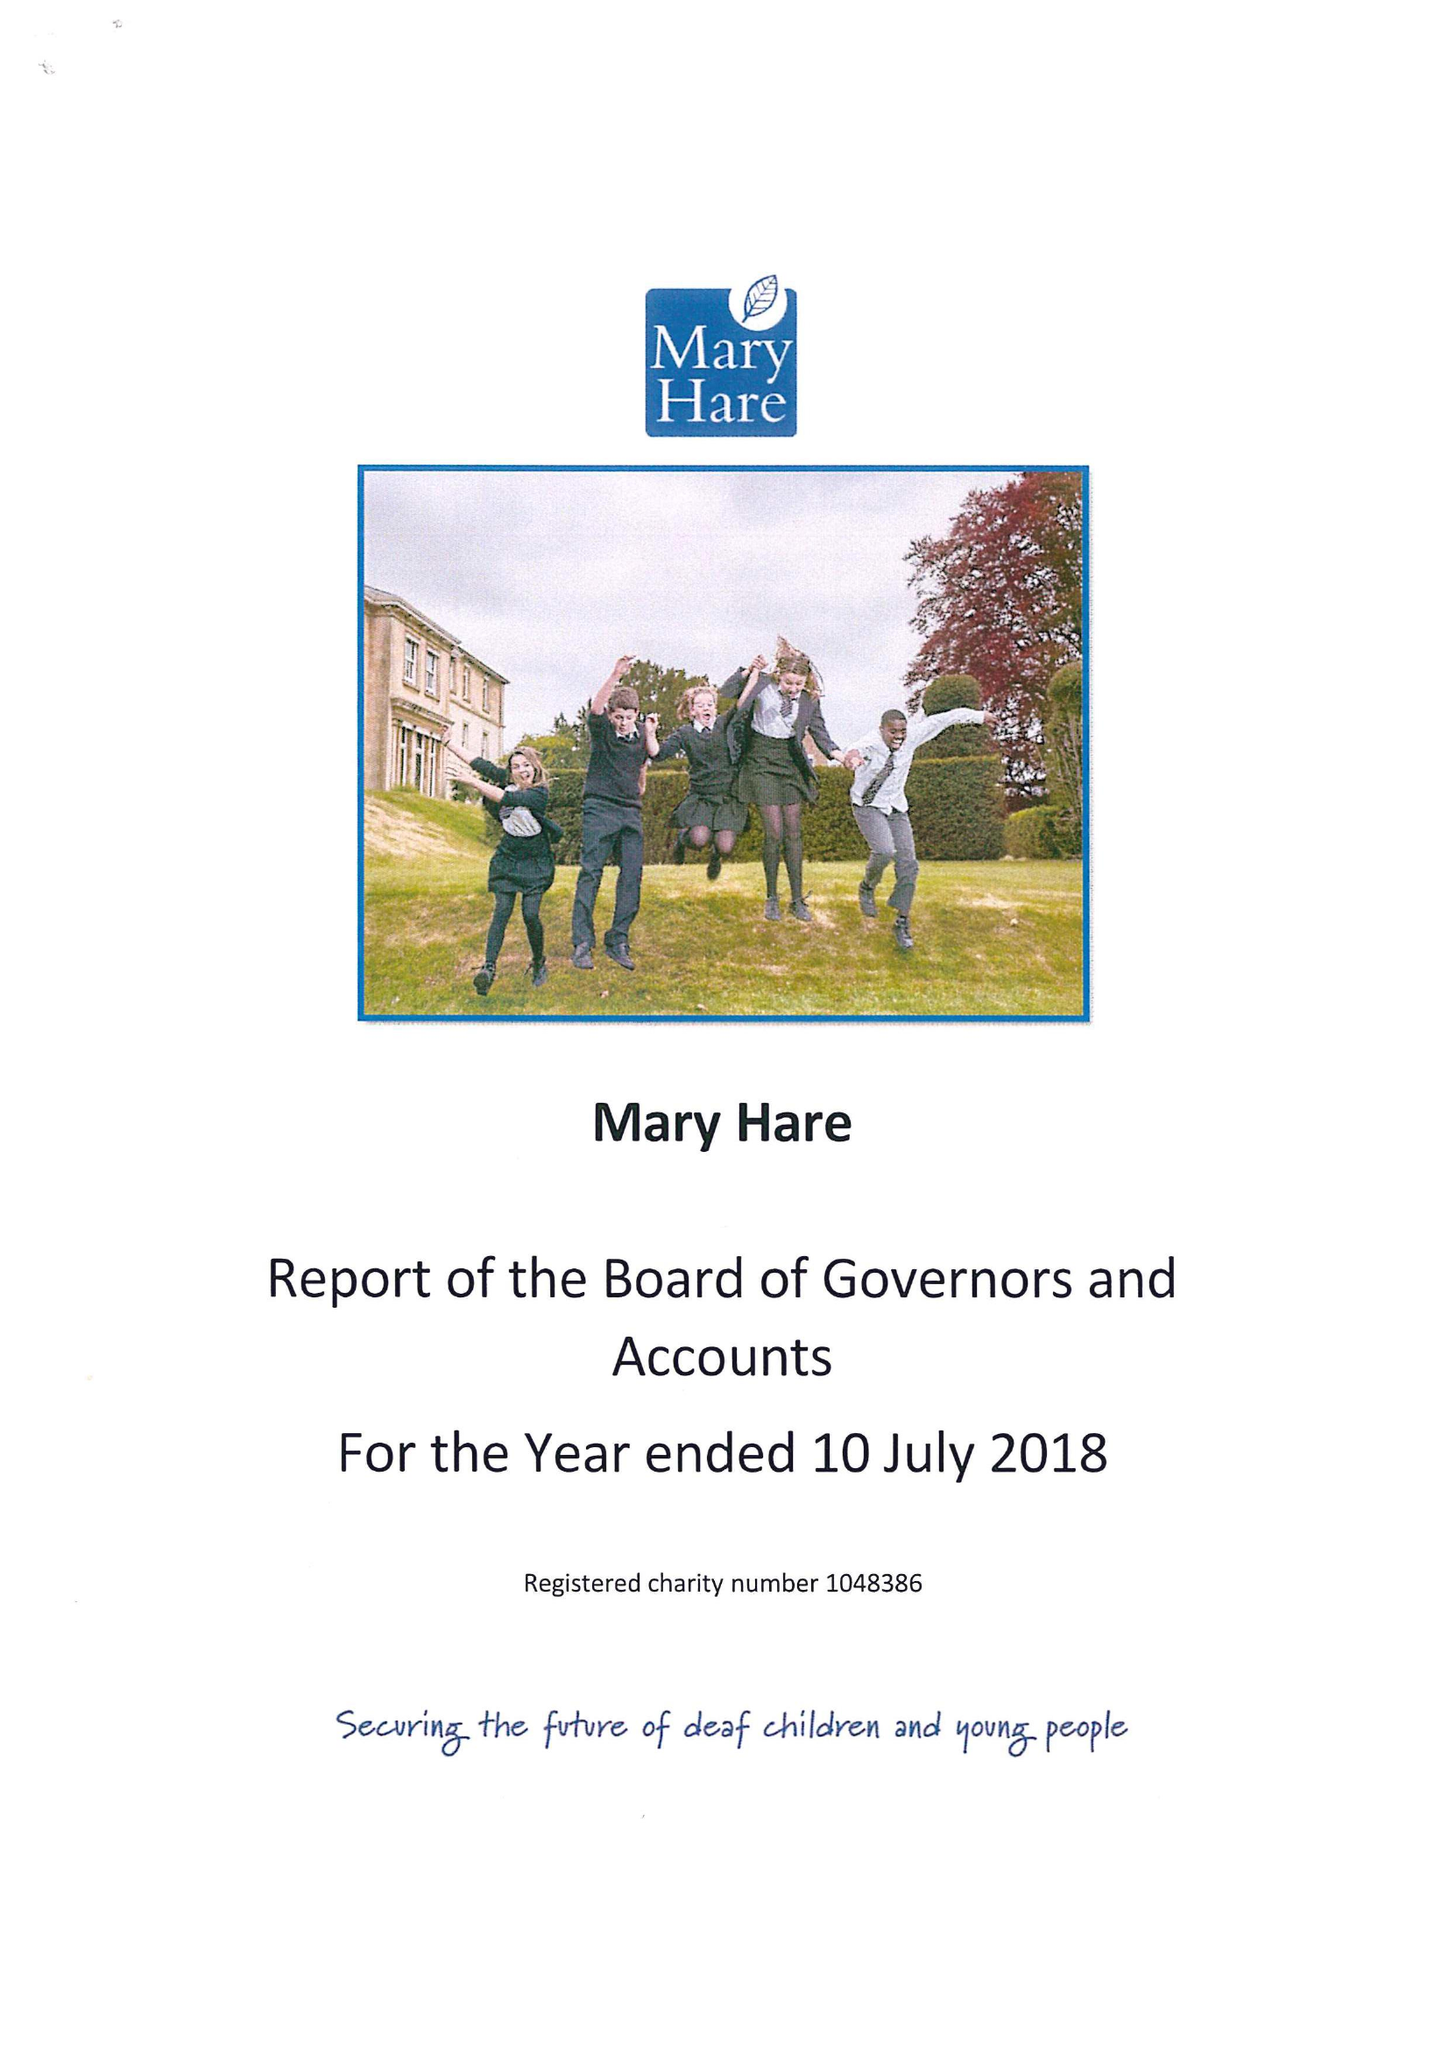What is the value for the charity_number?
Answer the question using a single word or phrase. 1048386 